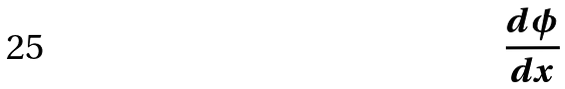Convert formula to latex. <formula><loc_0><loc_0><loc_500><loc_500>\frac { d \phi } { d x }</formula> 